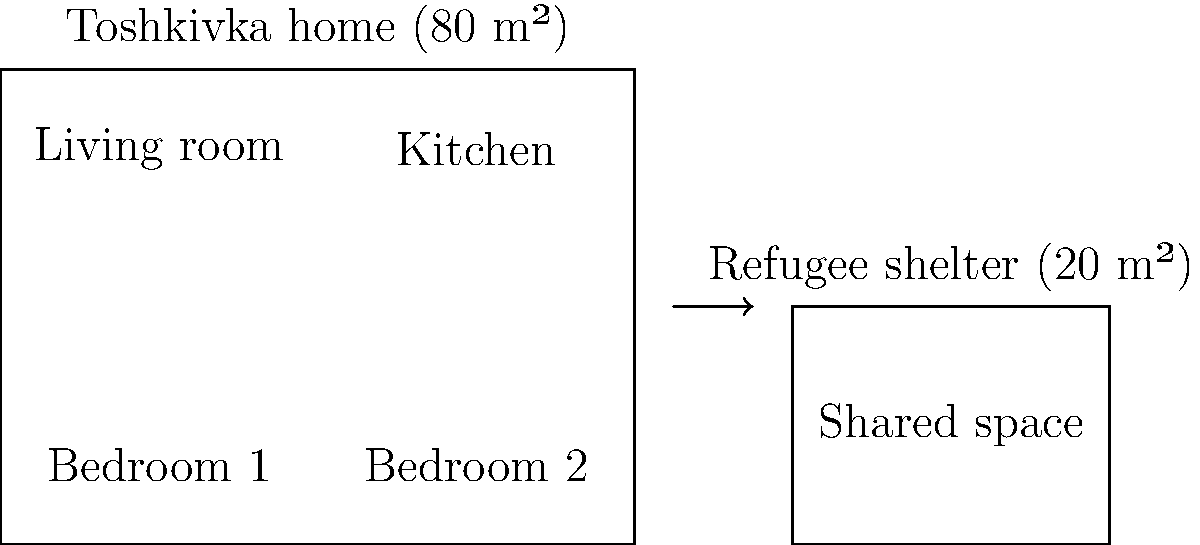Compare the floor plans of a typical Toshkivka home and refugee accommodation. Calculate the percentage reduction in living space when moving from the Toshkivka home to the refugee shelter. Round your answer to the nearest whole number. To calculate the percentage reduction in living space, we'll follow these steps:

1. Determine the area of the Toshkivka home:
   Area of Toshkivka home = 80 m²

2. Determine the area of the refugee shelter:
   Area of refugee shelter = 20 m²

3. Calculate the difference in area:
   Difference = 80 m² - 20 m² = 60 m²

4. Calculate the percentage reduction:
   Percentage reduction = (Difference / Original area) × 100
   = (60 m² / 80 m²) × 100
   = 0.75 × 100
   = 75%

5. Round to the nearest whole number:
   75% (no rounding needed in this case)

Therefore, the percentage reduction in living space is 75%.
Answer: 75% 